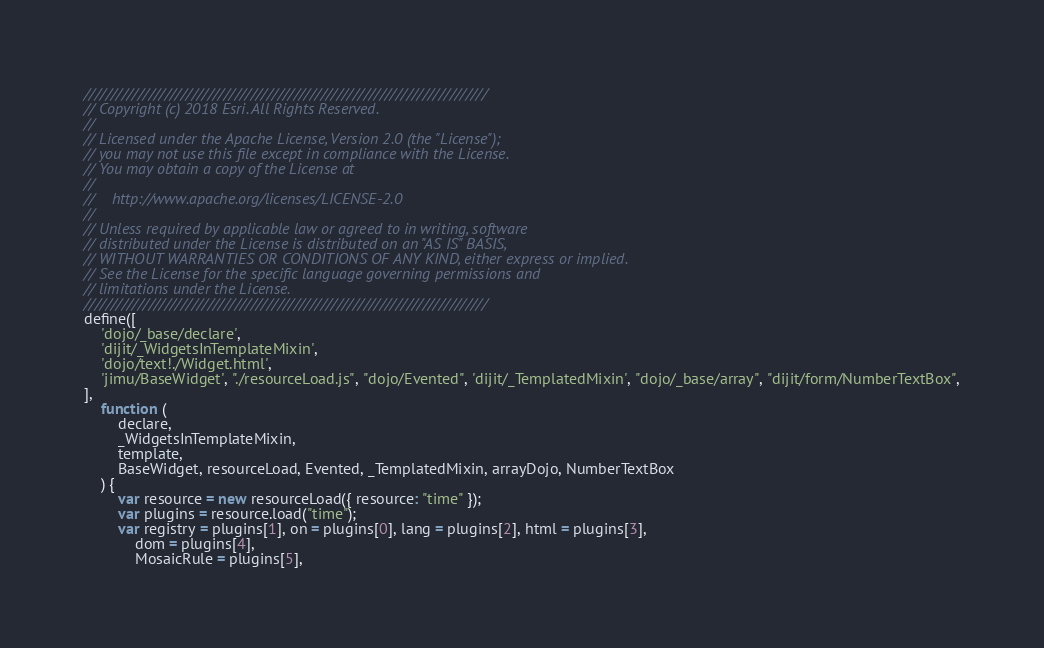<code> <loc_0><loc_0><loc_500><loc_500><_JavaScript_>///////////////////////////////////////////////////////////////////////////
// Copyright (c) 2018 Esri. All Rights Reserved.
//
// Licensed under the Apache License, Version 2.0 (the "License");
// you may not use this file except in compliance with the License.
// You may obtain a copy of the License at
//
//    http://www.apache.org/licenses/LICENSE-2.0
//
// Unless required by applicable law or agreed to in writing, software
// distributed under the License is distributed on an "AS IS" BASIS,
// WITHOUT WARRANTIES OR CONDITIONS OF ANY KIND, either express or implied.
// See the License for the specific language governing permissions and
// limitations under the License.
///////////////////////////////////////////////////////////////////////////
define([
    'dojo/_base/declare',
    'dijit/_WidgetsInTemplateMixin',
    'dojo/text!./Widget.html',
    'jimu/BaseWidget', "./resourceLoad.js", "dojo/Evented", 'dijit/_TemplatedMixin', "dojo/_base/array", "dijit/form/NumberTextBox",
],
    function (
        declare,
        _WidgetsInTemplateMixin,
        template,
        BaseWidget, resourceLoad, Evented, _TemplatedMixin, arrayDojo, NumberTextBox
    ) {
        var resource = new resourceLoad({ resource: "time" });
        var plugins = resource.load("time");
        var registry = plugins[1], on = plugins[0], lang = plugins[2], html = plugins[3],
            dom = plugins[4],
            MosaicRule = plugins[5],</code> 